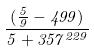Convert formula to latex. <formula><loc_0><loc_0><loc_500><loc_500>\frac { ( \frac { 5 } { 9 } - 4 9 9 ) } { 5 + 3 5 7 ^ { 2 2 9 } }</formula> 